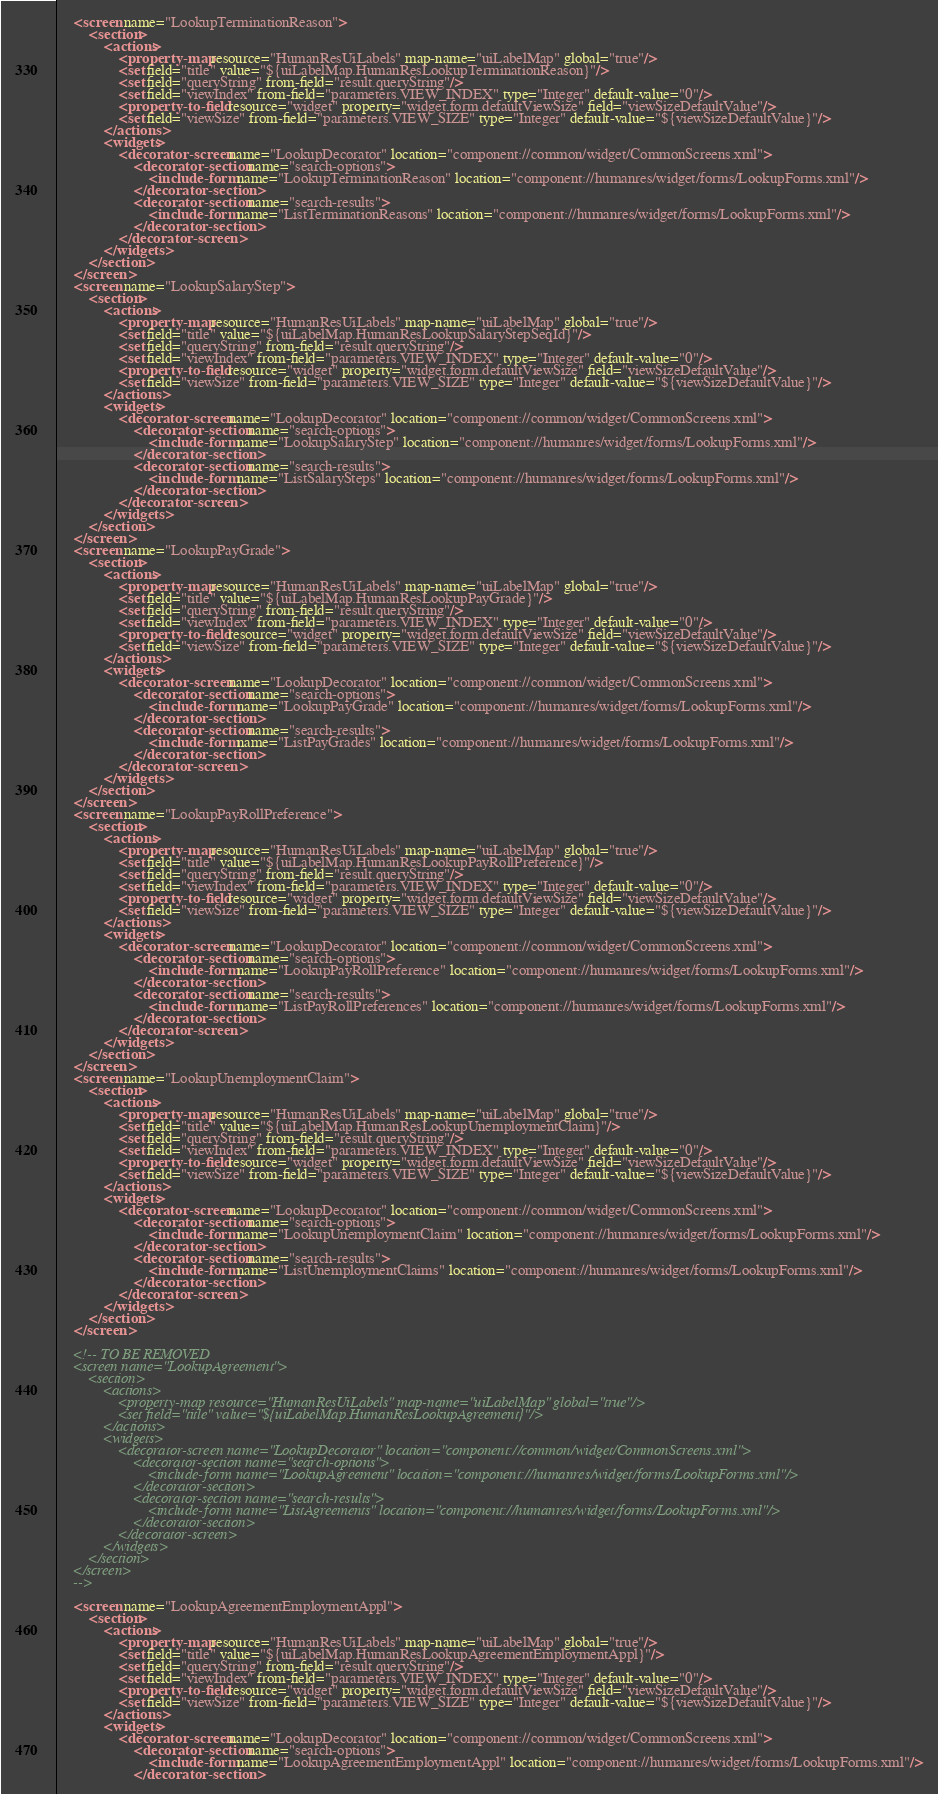<code> <loc_0><loc_0><loc_500><loc_500><_XML_>    <screen name="LookupTerminationReason">
        <section>
            <actions>
                <property-map resource="HumanResUiLabels" map-name="uiLabelMap" global="true"/>
                <set field="title" value="${uiLabelMap.HumanResLookupTerminationReason}"/>
                <set field="queryString" from-field="result.queryString"/>
                <set field="viewIndex" from-field="parameters.VIEW_INDEX" type="Integer" default-value="0"/>
                <property-to-field resource="widget" property="widget.form.defaultViewSize" field="viewSizeDefaultValue"/>
                <set field="viewSize" from-field="parameters.VIEW_SIZE" type="Integer" default-value="${viewSizeDefaultValue}"/>
            </actions>
            <widgets>
                <decorator-screen name="LookupDecorator" location="component://common/widget/CommonScreens.xml">
                    <decorator-section name="search-options">
                        <include-form name="LookupTerminationReason" location="component://humanres/widget/forms/LookupForms.xml"/>
                    </decorator-section>
                    <decorator-section name="search-results">
                        <include-form name="ListTerminationReasons" location="component://humanres/widget/forms/LookupForms.xml"/>
                    </decorator-section>
                </decorator-screen>
            </widgets>
        </section>
    </screen>
    <screen name="LookupSalaryStep">
        <section>
            <actions>
                <property-map resource="HumanResUiLabels" map-name="uiLabelMap" global="true"/>
                <set field="title" value="${uiLabelMap.HumanResLookupSalaryStepSeqId}"/>
                <set field="queryString" from-field="result.queryString"/>
                <set field="viewIndex" from-field="parameters.VIEW_INDEX" type="Integer" default-value="0"/>
                <property-to-field resource="widget" property="widget.form.defaultViewSize" field="viewSizeDefaultValue"/>
                <set field="viewSize" from-field="parameters.VIEW_SIZE" type="Integer" default-value="${viewSizeDefaultValue}"/>
            </actions>
            <widgets>
                <decorator-screen name="LookupDecorator" location="component://common/widget/CommonScreens.xml">
                    <decorator-section name="search-options">
                        <include-form name="LookupSalaryStep" location="component://humanres/widget/forms/LookupForms.xml"/>
                    </decorator-section>
                    <decorator-section name="search-results">
                        <include-form name="ListSalarySteps" location="component://humanres/widget/forms/LookupForms.xml"/>
                    </decorator-section>
                </decorator-screen>
            </widgets>
        </section>
    </screen>
    <screen name="LookupPayGrade">
        <section>
            <actions>
                <property-map resource="HumanResUiLabels" map-name="uiLabelMap" global="true"/>
                <set field="title" value="${uiLabelMap.HumanResLookupPayGrade}"/>
                <set field="queryString" from-field="result.queryString"/>
                <set field="viewIndex" from-field="parameters.VIEW_INDEX" type="Integer" default-value="0"/>
                <property-to-field resource="widget" property="widget.form.defaultViewSize" field="viewSizeDefaultValue"/>
                <set field="viewSize" from-field="parameters.VIEW_SIZE" type="Integer" default-value="${viewSizeDefaultValue}"/>
            </actions>
            <widgets>
                <decorator-screen name="LookupDecorator" location="component://common/widget/CommonScreens.xml">
                    <decorator-section name="search-options">
                        <include-form name="LookupPayGrade" location="component://humanres/widget/forms/LookupForms.xml"/>
                    </decorator-section>
                    <decorator-section name="search-results">
                        <include-form name="ListPayGrades" location="component://humanres/widget/forms/LookupForms.xml"/>
                    </decorator-section>
                </decorator-screen>
            </widgets>
        </section>
    </screen>
    <screen name="LookupPayRollPreference">
        <section>
            <actions>
                <property-map resource="HumanResUiLabels" map-name="uiLabelMap" global="true"/>
                <set field="title" value="${uiLabelMap.HumanResLookupPayRollPreference}"/>
                <set field="queryString" from-field="result.queryString"/>
                <set field="viewIndex" from-field="parameters.VIEW_INDEX" type="Integer" default-value="0"/>
                <property-to-field resource="widget" property="widget.form.defaultViewSize" field="viewSizeDefaultValue"/>
                <set field="viewSize" from-field="parameters.VIEW_SIZE" type="Integer" default-value="${viewSizeDefaultValue}"/>
            </actions>
            <widgets>
                <decorator-screen name="LookupDecorator" location="component://common/widget/CommonScreens.xml">
                    <decorator-section name="search-options">
                        <include-form name="LookupPayRollPreference" location="component://humanres/widget/forms/LookupForms.xml"/>
                    </decorator-section>
                    <decorator-section name="search-results">
                        <include-form name="ListPayRollPreferences" location="component://humanres/widget/forms/LookupForms.xml"/>
                    </decorator-section>
                </decorator-screen>
            </widgets>
        </section>
    </screen>
    <screen name="LookupUnemploymentClaim">
        <section>
            <actions>
                <property-map resource="HumanResUiLabels" map-name="uiLabelMap" global="true"/>
                <set field="title" value="${uiLabelMap.HumanResLookupUnemploymentClaim}"/>
                <set field="queryString" from-field="result.queryString"/>
                <set field="viewIndex" from-field="parameters.VIEW_INDEX" type="Integer" default-value="0"/>
                <property-to-field resource="widget" property="widget.form.defaultViewSize" field="viewSizeDefaultValue"/>
                <set field="viewSize" from-field="parameters.VIEW_SIZE" type="Integer" default-value="${viewSizeDefaultValue}"/>
            </actions>
            <widgets>
                <decorator-screen name="LookupDecorator" location="component://common/widget/CommonScreens.xml">
                    <decorator-section name="search-options">
                        <include-form name="LookupUnemploymentClaim" location="component://humanres/widget/forms/LookupForms.xml"/>
                    </decorator-section>
                    <decorator-section name="search-results">
                        <include-form name="ListUnemploymentClaims" location="component://humanres/widget/forms/LookupForms.xml"/>
                    </decorator-section>
                </decorator-screen>
            </widgets>
        </section>
    </screen>

    <!-- TO BE REMOVED
    <screen name="LookupAgreement">
        <section>
            <actions>
                <property-map resource="HumanResUiLabels" map-name="uiLabelMap" global="true"/>
                <set field="title" value="${uiLabelMap.HumanResLookupAgreement}"/>
            </actions>
            <widgets>
                <decorator-screen name="LookupDecorator" location="component://common/widget/CommonScreens.xml">
                    <decorator-section name="search-options">
                        <include-form name="LookupAgreement" location="component://humanres/widget/forms/LookupForms.xml"/>
                    </decorator-section>
                    <decorator-section name="search-results">
                        <include-form name="ListAgreements" location="component://humanres/widget/forms/LookupForms.xml"/>
                    </decorator-section>
                </decorator-screen>
            </widgets>
        </section>
    </screen>
    -->

    <screen name="LookupAgreementEmploymentAppl">
        <section>
            <actions>
                <property-map resource="HumanResUiLabels" map-name="uiLabelMap" global="true"/>
                <set field="title" value="${uiLabelMap.HumanResLookupAgreementEmploymentAppl}"/>
                <set field="queryString" from-field="result.queryString"/>
                <set field="viewIndex" from-field="parameters.VIEW_INDEX" type="Integer" default-value="0"/>
                <property-to-field resource="widget" property="widget.form.defaultViewSize" field="viewSizeDefaultValue"/>
                <set field="viewSize" from-field="parameters.VIEW_SIZE" type="Integer" default-value="${viewSizeDefaultValue}"/>
            </actions>
            <widgets>
                <decorator-screen name="LookupDecorator" location="component://common/widget/CommonScreens.xml">
                    <decorator-section name="search-options">
                        <include-form name="LookupAgreementEmploymentAppl" location="component://humanres/widget/forms/LookupForms.xml"/>
                    </decorator-section></code> 